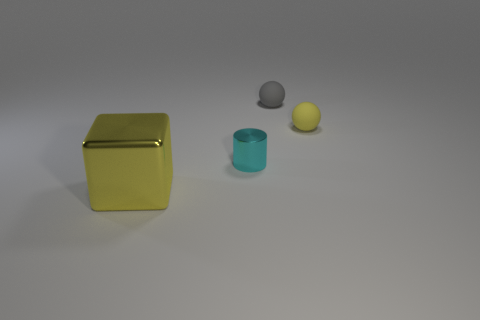Add 2 big yellow metallic blocks. How many objects exist? 6 Subtract all gray spheres. How many spheres are left? 1 Subtract 1 cylinders. How many cylinders are left? 0 Subtract all cyan cubes. Subtract all purple cylinders. How many cubes are left? 1 Add 3 yellow matte objects. How many yellow matte objects exist? 4 Subtract 0 gray blocks. How many objects are left? 4 Subtract all cylinders. How many objects are left? 3 Subtract all green cylinders. How many yellow balls are left? 1 Subtract all brown metal things. Subtract all gray balls. How many objects are left? 3 Add 2 small matte things. How many small matte things are left? 4 